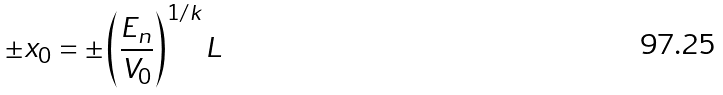<formula> <loc_0><loc_0><loc_500><loc_500>\pm x _ { 0 } = \pm \left ( \frac { E _ { n } } { V _ { 0 } } \right ) ^ { 1 / k } L</formula> 